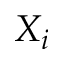Convert formula to latex. <formula><loc_0><loc_0><loc_500><loc_500>X _ { i }</formula> 